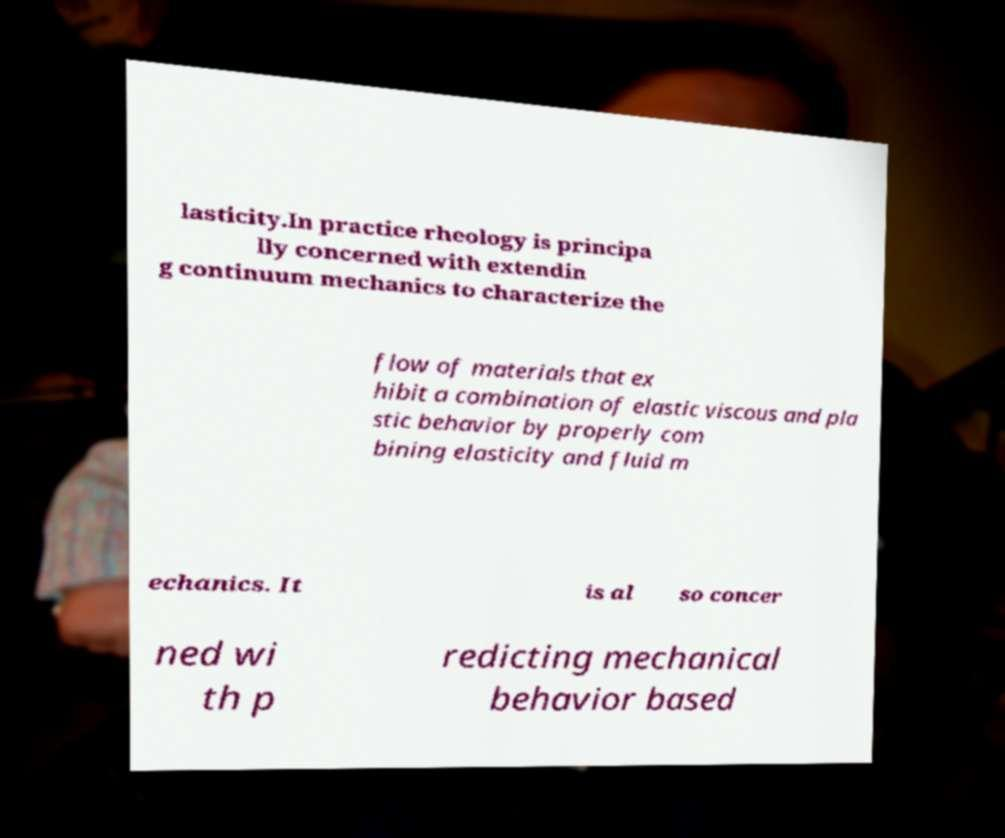Could you extract and type out the text from this image? lasticity.In practice rheology is principa lly concerned with extendin g continuum mechanics to characterize the flow of materials that ex hibit a combination of elastic viscous and pla stic behavior by properly com bining elasticity and fluid m echanics. It is al so concer ned wi th p redicting mechanical behavior based 